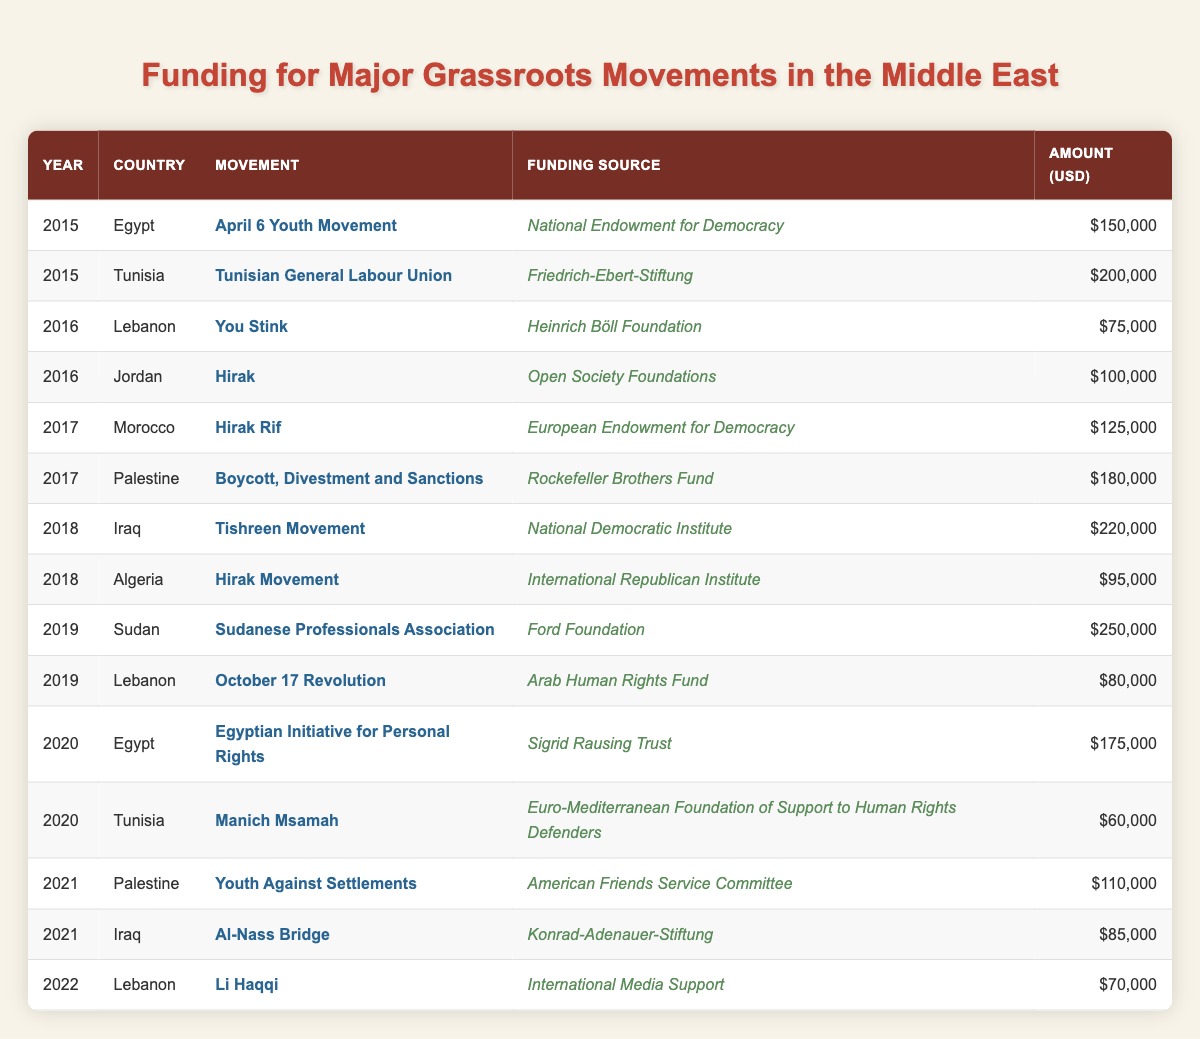What was the funding amount for the April 6 Youth Movement in Egypt in 2015? According to the table, the funding amount for the April 6 Youth Movement in Egypt in 2015 is clearly listed as $150,000.
Answer: $150,000 Which movement received funding from the Ford Foundation in 2019? The table specifies that the Sudanese Professionals Association received funding from the Ford Foundation in 2019.
Answer: Sudanese Professionals Association What is the total funding amount for grassroots movements in Iraq over the years listed? To find the total funding for Iraq, we look at the amounts: $220,000 (2018) + $85,000 (2021) = $305,000. Therefore, the total funding amount for grassroots movements in Iraq is $305,000.
Answer: $305,000 Did the Tunisian General Labour Union receive more funding than the Youth Against Settlements movement? The Tunisian General Labour Union received $200,000 in 2015, while the Youth Against Settlements received $110,000 in 2021. Thus, the statement is true since $200,000 is greater than $110,000.
Answer: Yes What is the average funding received by grassroots movements in Lebanon from 2016 to 2022? In Lebanon, the movements recorded amounts are $75,000 (You Stink in 2016), $80,000 (October 17 Revolution in 2019), and $70,000 (Li Haqqi in 2022). The total is $75,000 + $80,000 + $70,000 = $225,000. There are three movements, so the average is $225,000 / 3 = $75,000.
Answer: $75,000 Which country had the highest single funding amount for grassroots movements in the table? By analyzing the amounts, we see that Sudan had the highest single funding amount of $250,000 for the Sudanese Professionals Association in 2019, which is the maximum in the entire table.
Answer: Sudan How many funding sources were recorded for movements in Algeria? The table shows that there is only one funding entry for movements in Algeria, which is for the Hirak Movement in 2018 with a funding source from the International Republican Institute.
Answer: 1 What changes occurred in the funding for Tunisia between 2015 and 2020? In 2015, the funding for the Tunisian General Labour Union was $200,000. In 2020, the funding for Manich Msamah was only $60,000. This indicates a decrease in funding for grassroots movements in Tunisia over the five years.
Answer: Decrease 